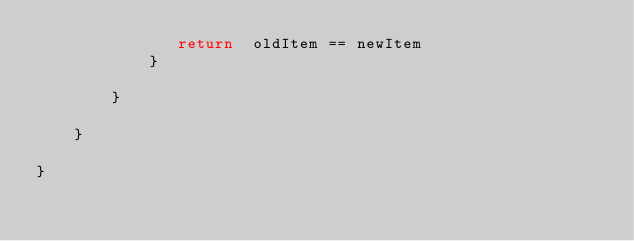Convert code to text. <code><loc_0><loc_0><loc_500><loc_500><_Kotlin_>               return  oldItem == newItem
            }

        }

    }

}





</code> 